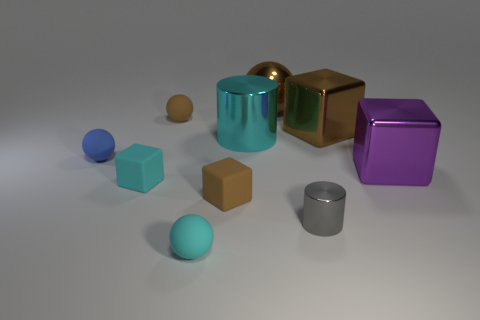Can you estimate which object is the heaviest based on its appearance? While it's challenging to establish weight by appearance alone, the golden cube's material resembles a heavy metal like brass or gold, contributing to the perception that it may be the heaviest object. However, without knowing the actual materials or density, this is a speculative observation. 